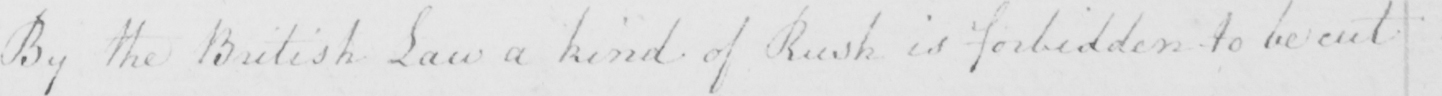Please provide the text content of this handwritten line. By the British Law a kind of Rush is forbidden to be cut 